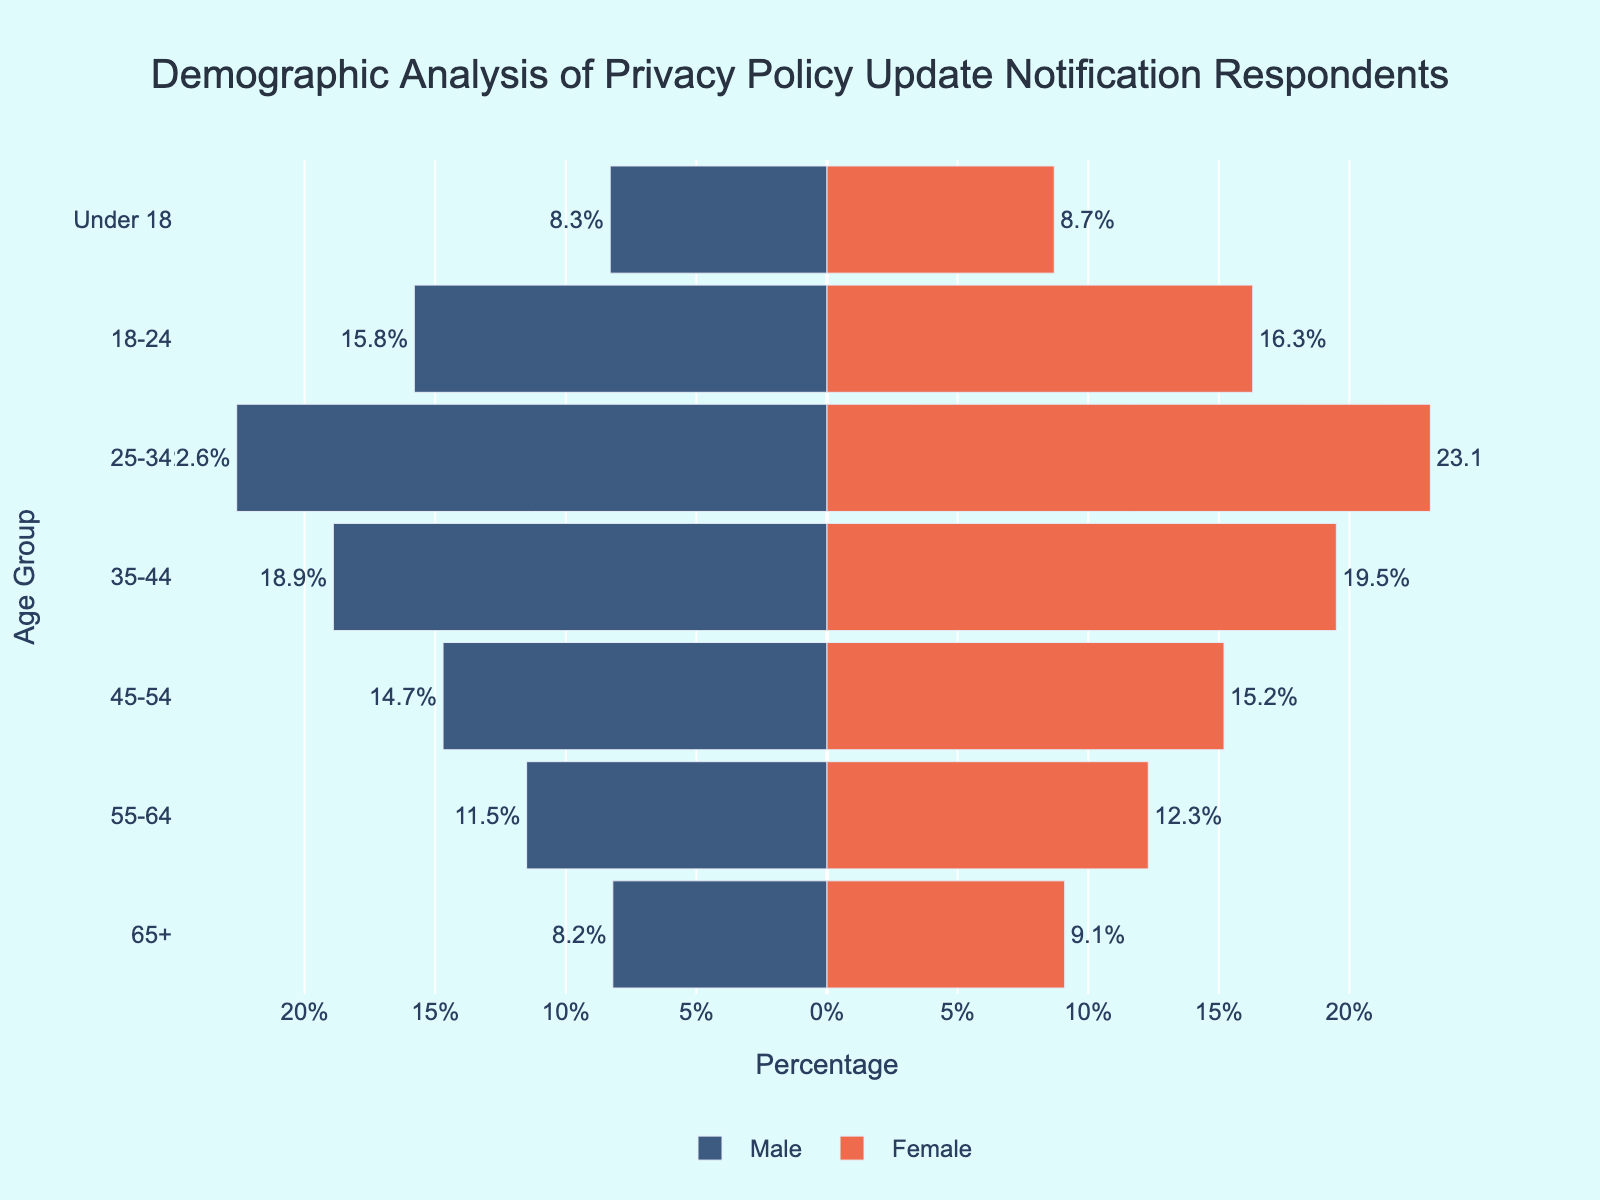What's the title of the figure? The title is centered at the top of the figure as indicated in the layout properties.
Answer: Demographic Analysis of Privacy Policy Update Notification Respondents What age group has the highest percentage of female respondents? Looking at the height of the bars for female respondents, the "25-34" age group has the tallest bar on the right side of the pyramid.
Answer: 25-34 What's the percentage difference between male and female respondents in the "35-44" age group? Female percentage is 19.5 and male percentage is 18.9. The difference is calculated as 19.5 - 18.9.
Answer: 0.6 Which gender has more respondents in the "45-54" age group? The bar for female respondents in the "45-54" age group is slightly longer than the bar for male respondents.
Answer: Female What is the total percentage of respondents in the "55-64" age group? Summing the percentages of males and females for this age group: 11.5 + 12.3 = 23.8.
Answer: 23.8 How does the percentage of respondents under 18 compare between males and females? The percentage for females is 8.7, and the percentage for males is 8.3. The female percentage is slightly higher.
Answer: Female Which age group has the largest disparity between male and female respondents? By comparing the lengths of the male and female bars for each age group, the "45-54" age group has the largest visible difference between male (14.7) and female (15.2) respondents.
Answer: 45-54 What is the combined percentage of male and female respondents aged 18-24? Combining the male and female percentages for the "18-24" age group: 15.8 + 16.3 = 32.1.
Answer: 32.1 Does any age group have an equal proportion of male and female respondents? By comparing the lengths of the bars, no age group has exactly equal proportions of male and female respondents.
Answer: No How many age groups have more than 15% female respondents each? Checking each age group, those with more than 15% female are: 45-54, 35-44, 25-34, and 18-24; totaling 4 age groups.
Answer: 4 